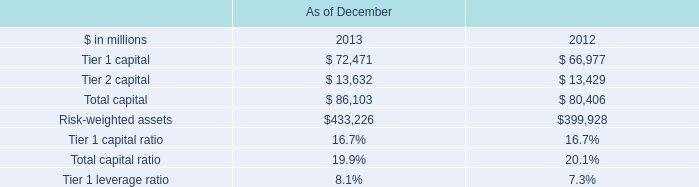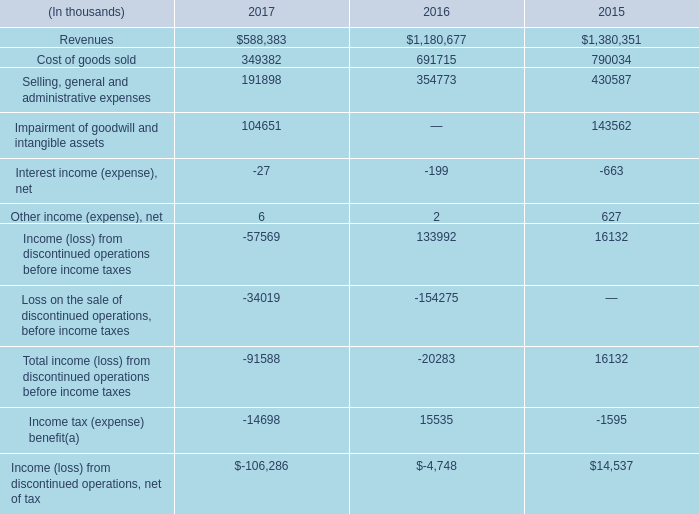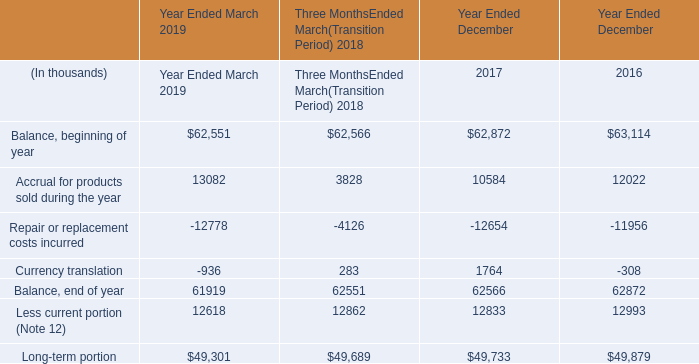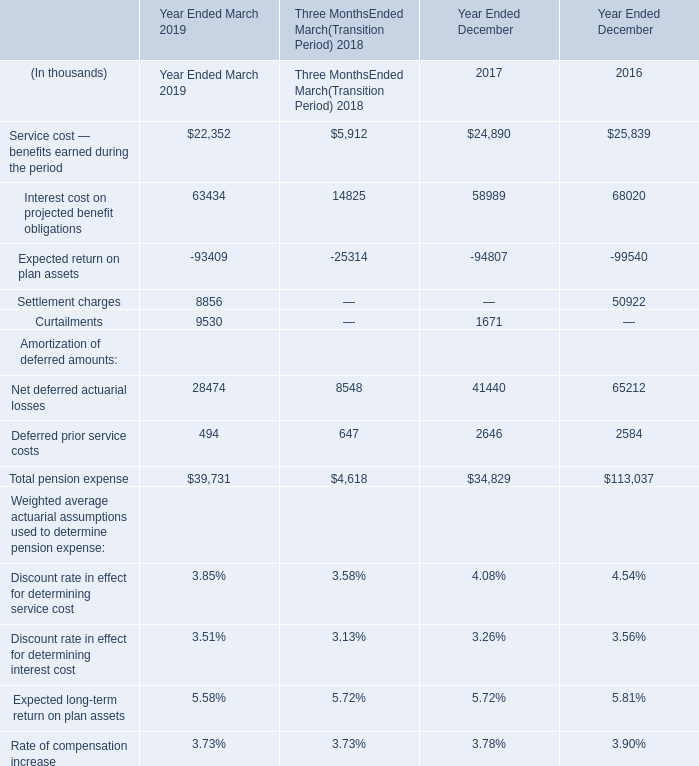What is the proportion of all pension expense that are greater than 20000 to the total amount of pension expense, in Year Ended March 2019 ? 
Computations: (((22352 + 63434) + 28474) / 39731)
Answer: 2.87584. 